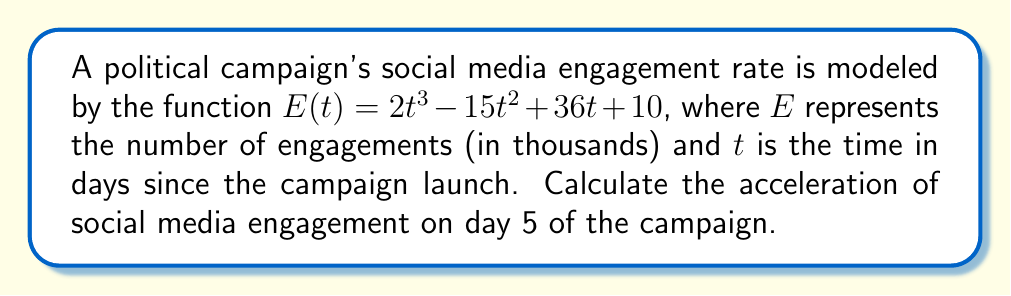Teach me how to tackle this problem. To find the acceleration of social media engagement, we need to calculate the second derivative of the given function $E(t)$.

Step 1: Find the first derivative (velocity of engagement)
$$\frac{dE}{dt} = E'(t) = 6t^2 - 30t + 36$$

Step 2: Find the second derivative (acceleration of engagement)
$$\frac{d^2E}{dt^2} = E''(t) = 12t - 30$$

Step 3: Calculate the acceleration at day 5 by substituting $t = 5$ into the second derivative
$$E''(5) = 12(5) - 30 = 60 - 30 = 30$$

The acceleration of social media engagement on day 5 is 30 thousand engagements per day squared.
Answer: $30$ thousand engagements/day² 